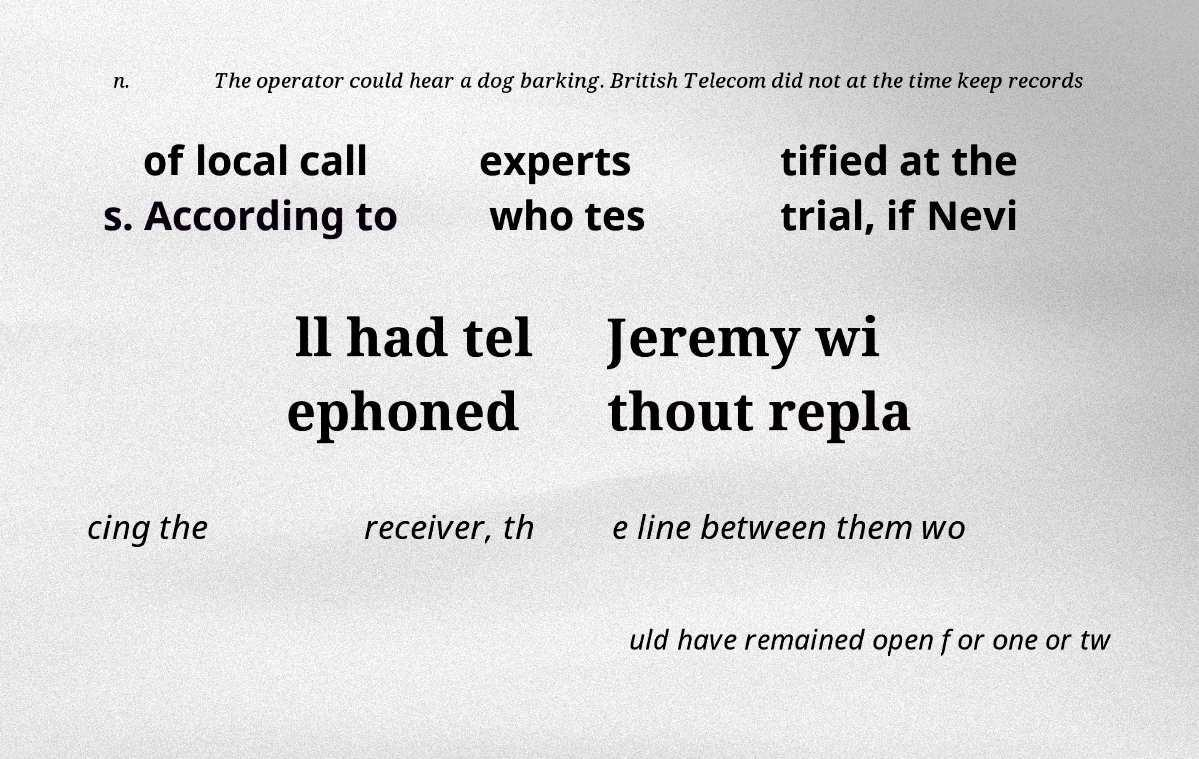What messages or text are displayed in this image? I need them in a readable, typed format. n. The operator could hear a dog barking. British Telecom did not at the time keep records of local call s. According to experts who tes tified at the trial, if Nevi ll had tel ephoned Jeremy wi thout repla cing the receiver, th e line between them wo uld have remained open for one or tw 